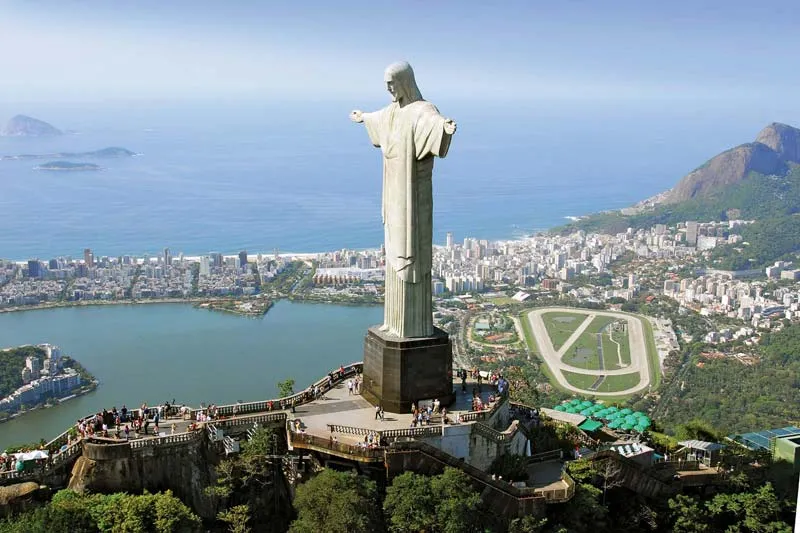What is the significance of the Christ the Redeemer statue in Brazilian culture? The Christ the Redeemer statue is a symbol of Christianity across the world and a cultural icon of both Rio de Janeiro and Brazil. Unveiled in 1931, it has become an emblem of Brazil's religious and cultural heritage. The statue's outstretched arms demonstrate a gesture of peace and welcome, representing Brazilian hospitality and openness. Moreover, it plays a significant role during major events, such as the annual Rio Carnival and global events like the World Cup and the Olympics, standing as a backdrop that symbolizes hope, unity, and faith for people around the globe. 